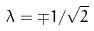<formula> <loc_0><loc_0><loc_500><loc_500>\lambda = \mp 1 / \sqrt { 2 }</formula> 